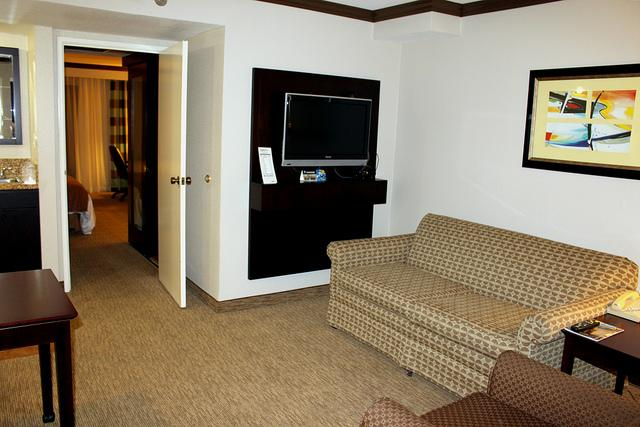Which country is famous for paintings? Please explain your reasoning. rome italy. Rome is known for famous paintings. 